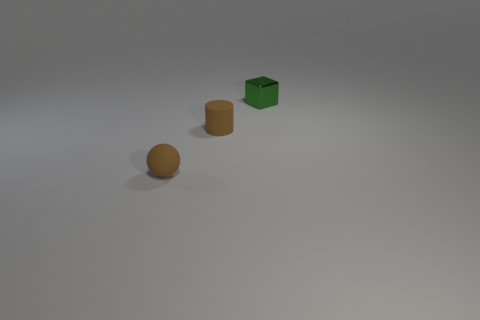What is the material of the small object that is in front of the tiny brown matte thing behind the tiny brown rubber sphere?
Give a very brief answer. Rubber. What number of things are small matte balls or small green things?
Provide a succinct answer. 2. There is a sphere that is the same color as the tiny cylinder; what is its size?
Provide a short and direct response. Small. Are there fewer metallic objects than things?
Your answer should be compact. Yes. There is a brown cylinder that is the same material as the ball; what size is it?
Your answer should be very brief. Small. The metallic object has what size?
Give a very brief answer. Small. What is the shape of the small green object?
Your answer should be compact. Cube. There is a matte object that is on the right side of the brown matte sphere; is it the same color as the small rubber sphere?
Keep it short and to the point. Yes. Is there anything else that is the same material as the small green block?
Provide a short and direct response. No. Are there any small cylinders that are in front of the small brown rubber object that is behind the thing that is left of the rubber cylinder?
Keep it short and to the point. No. 